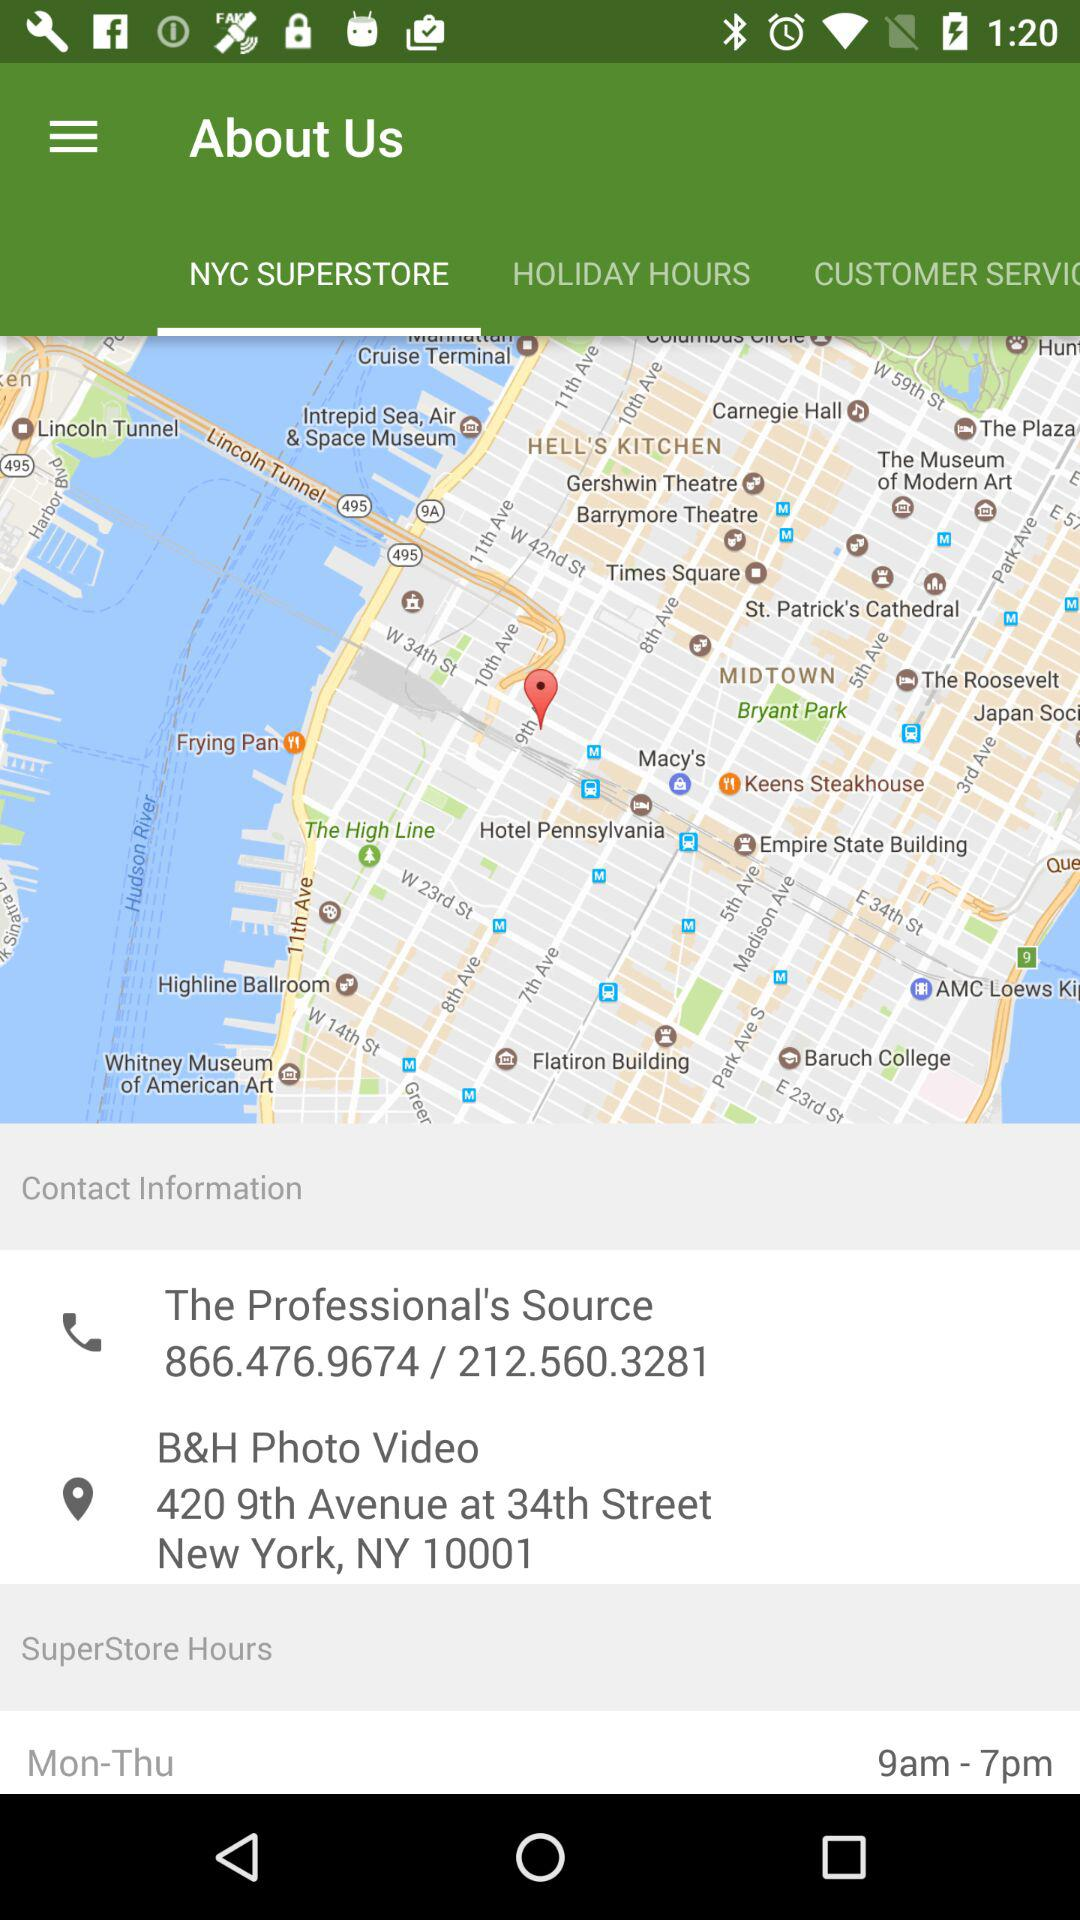What is the contact number? The contact numbers are 866.476.9674 and 212.560.3281. 